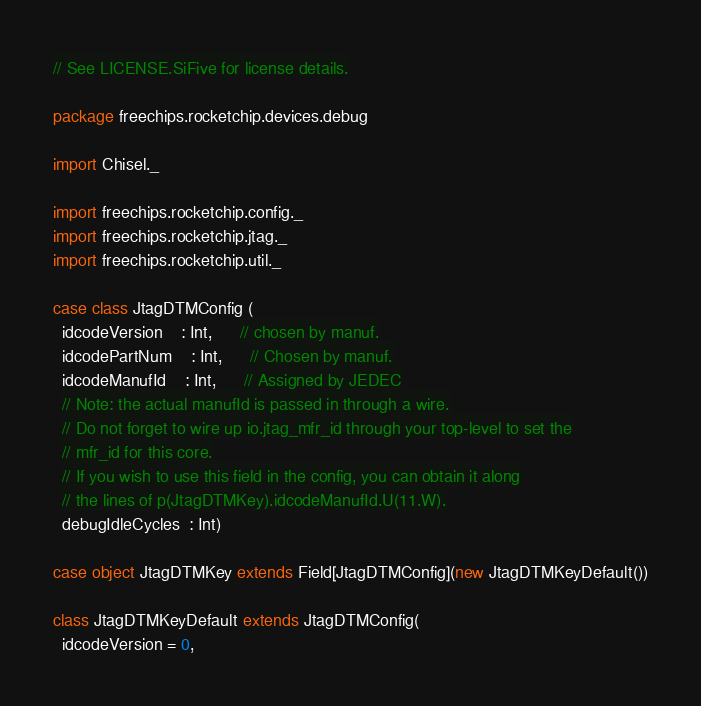Convert code to text. <code><loc_0><loc_0><loc_500><loc_500><_Scala_>// See LICENSE.SiFive for license details.

package freechips.rocketchip.devices.debug

import Chisel._

import freechips.rocketchip.config._
import freechips.rocketchip.jtag._
import freechips.rocketchip.util._

case class JtagDTMConfig (
  idcodeVersion    : Int,      // chosen by manuf.
  idcodePartNum    : Int,      // Chosen by manuf.
  idcodeManufId    : Int,      // Assigned by JEDEC
  // Note: the actual manufId is passed in through a wire.
  // Do not forget to wire up io.jtag_mfr_id through your top-level to set the
  // mfr_id for this core.
  // If you wish to use this field in the config, you can obtain it along
  // the lines of p(JtagDTMKey).idcodeManufId.U(11.W).
  debugIdleCycles  : Int)

case object JtagDTMKey extends Field[JtagDTMConfig](new JtagDTMKeyDefault())

class JtagDTMKeyDefault extends JtagDTMConfig(
  idcodeVersion = 0,</code> 